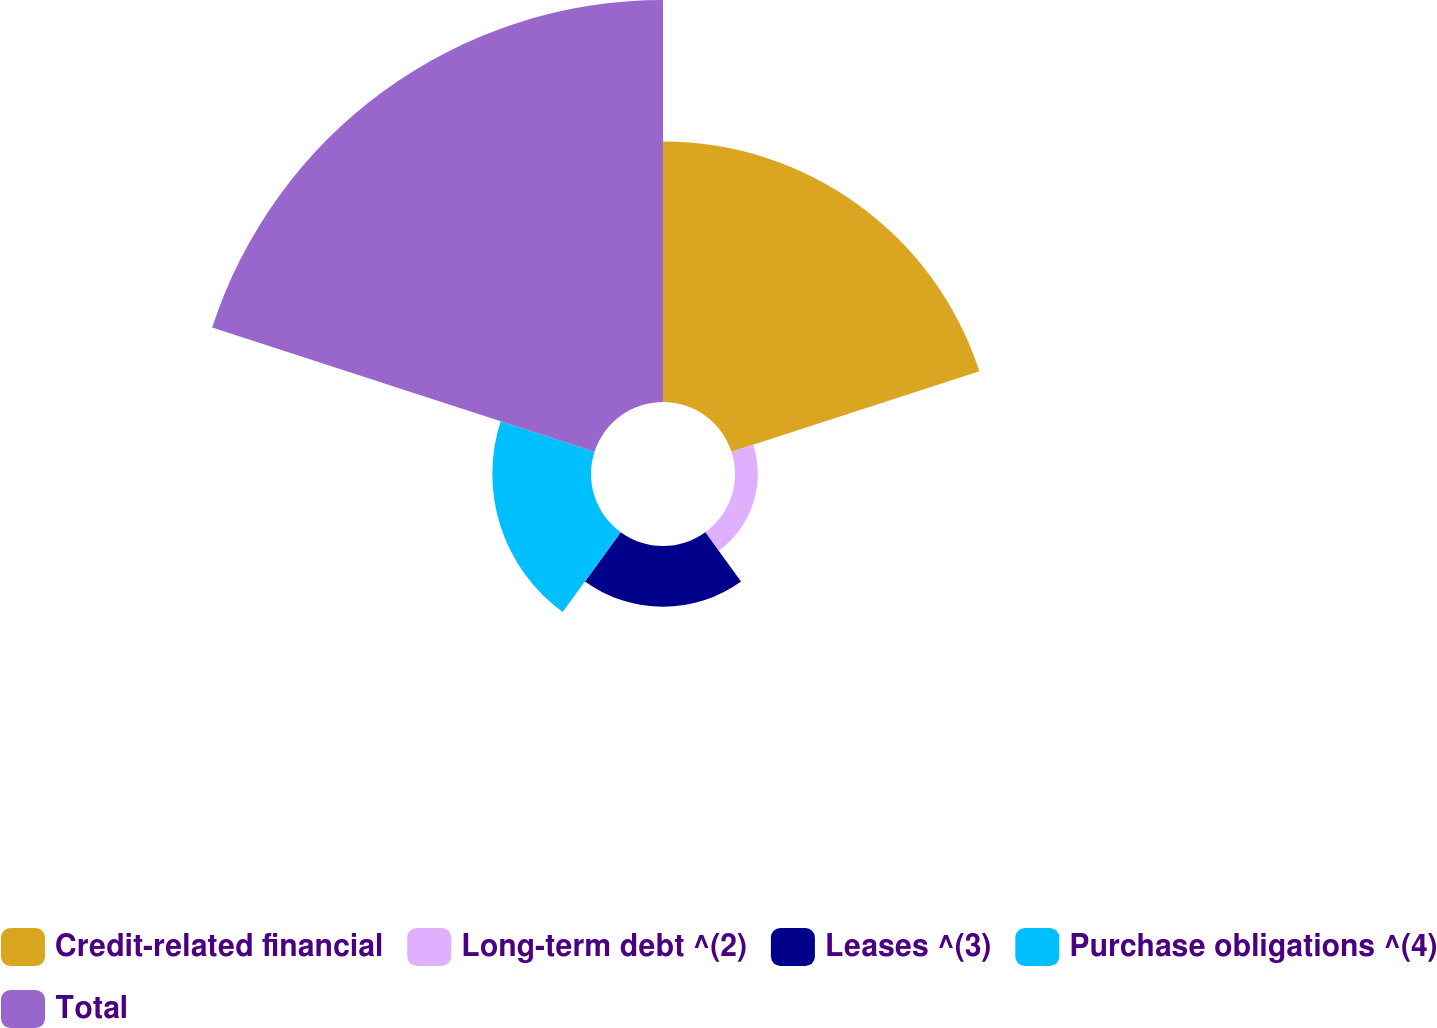Convert chart to OTSL. <chart><loc_0><loc_0><loc_500><loc_500><pie_chart><fcel>Credit-related financial<fcel>Long-term debt ^(2)<fcel>Leases ^(3)<fcel>Purchase obligations ^(4)<fcel>Total<nl><fcel>30.85%<fcel>2.7%<fcel>7.19%<fcel>11.68%<fcel>47.59%<nl></chart> 